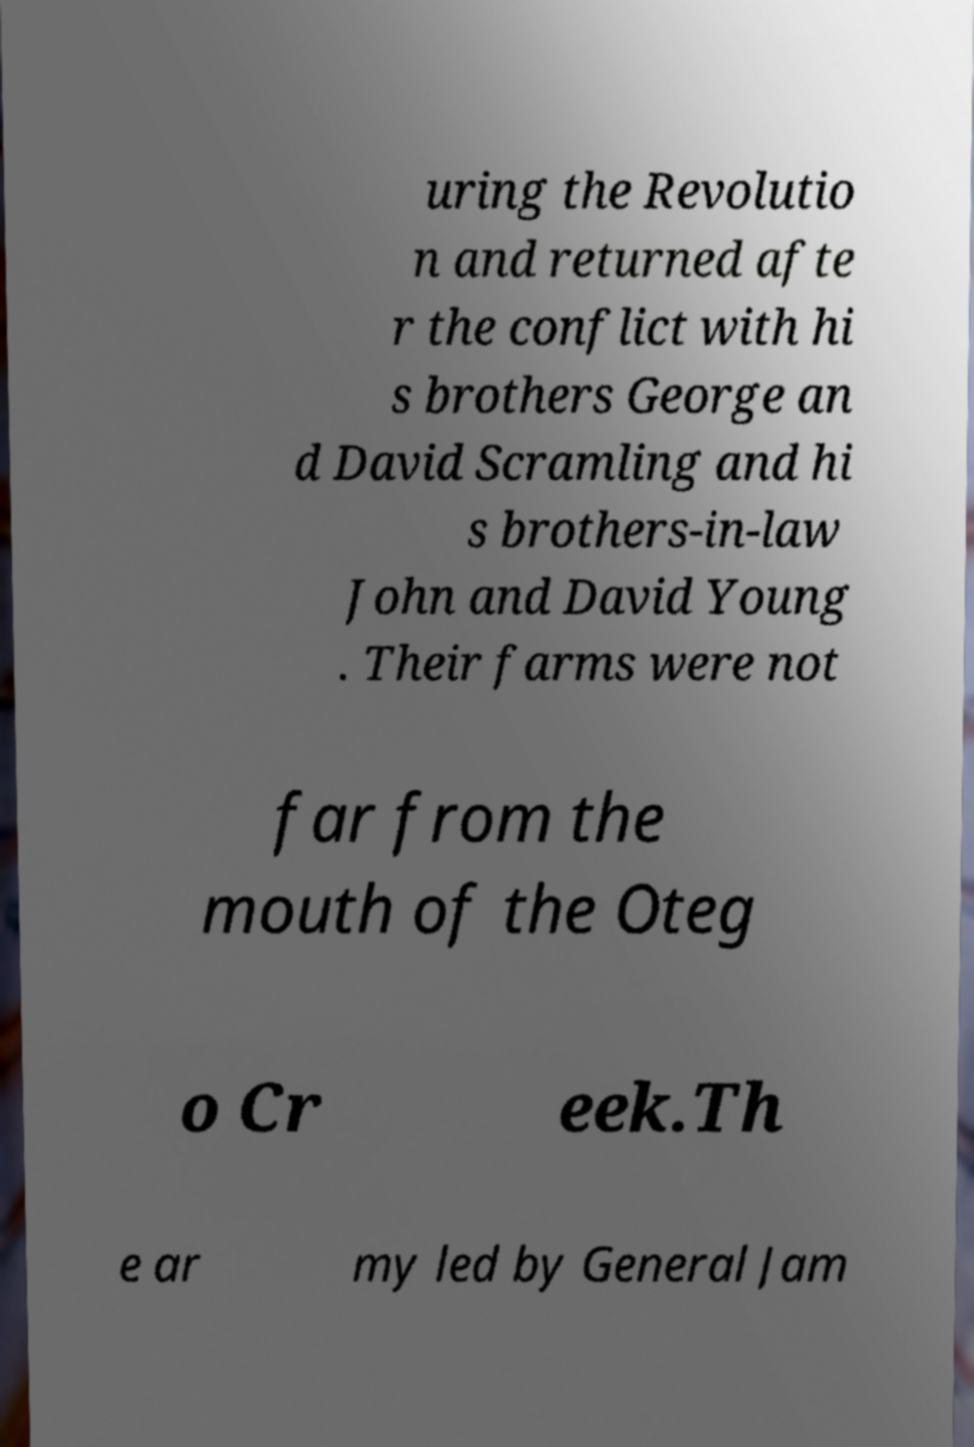What messages or text are displayed in this image? I need them in a readable, typed format. uring the Revolutio n and returned afte r the conflict with hi s brothers George an d David Scramling and hi s brothers-in-law John and David Young . Their farms were not far from the mouth of the Oteg o Cr eek.Th e ar my led by General Jam 